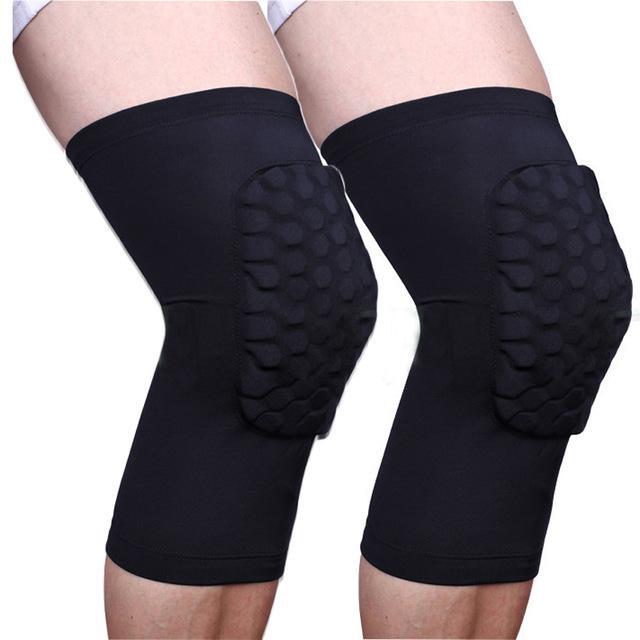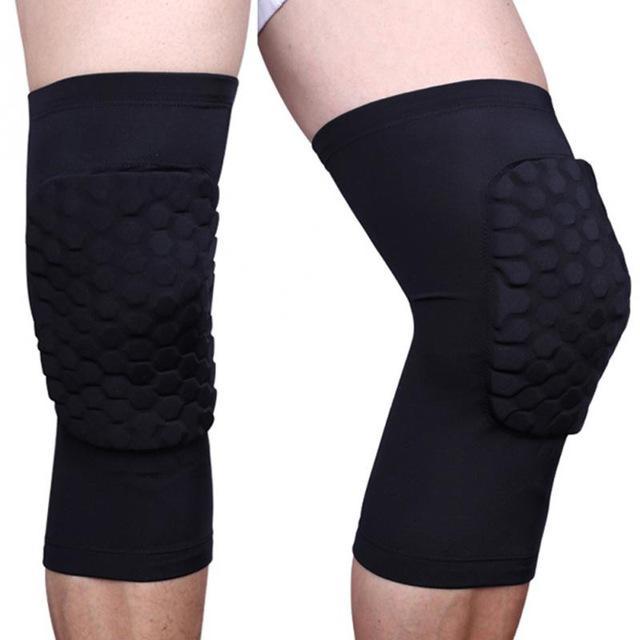The first image is the image on the left, the second image is the image on the right. Evaluate the accuracy of this statement regarding the images: "Each image shows a pair of legs, with just one leg wearing a black knee wrap.". Is it true? Answer yes or no. No. The first image is the image on the left, the second image is the image on the right. Given the left and right images, does the statement "The left and right image contains a total of two knee braces." hold true? Answer yes or no. No. 